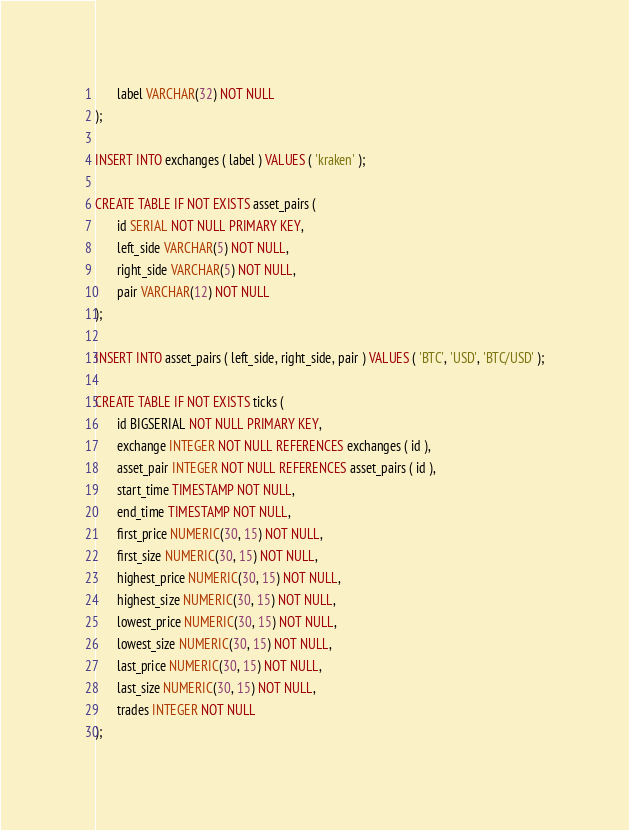<code> <loc_0><loc_0><loc_500><loc_500><_SQL_>       label VARCHAR(32) NOT NULL
);

INSERT INTO exchanges ( label ) VALUES ( 'kraken' );

CREATE TABLE IF NOT EXISTS asset_pairs (
       id SERIAL NOT NULL PRIMARY KEY,
       left_side VARCHAR(5) NOT NULL,
       right_side VARCHAR(5) NOT NULL,
       pair VARCHAR(12) NOT NULL
);

INSERT INTO asset_pairs ( left_side, right_side, pair ) VALUES ( 'BTC', 'USD', 'BTC/USD' );

CREATE TABLE IF NOT EXISTS ticks (
       id BIGSERIAL NOT NULL PRIMARY KEY,
       exchange INTEGER NOT NULL REFERENCES exchanges ( id ),
       asset_pair INTEGER NOT NULL REFERENCES asset_pairs ( id ),
       start_time TIMESTAMP NOT NULL,
       end_time TIMESTAMP NOT NULL,
       first_price NUMERIC(30, 15) NOT NULL,
       first_size NUMERIC(30, 15) NOT NULL,
       highest_price NUMERIC(30, 15) NOT NULL,
       highest_size NUMERIC(30, 15) NOT NULL,
       lowest_price NUMERIC(30, 15) NOT NULL,
       lowest_size NUMERIC(30, 15) NOT NULL,
       last_price NUMERIC(30, 15) NOT NULL,
       last_size NUMERIC(30, 15) NOT NULL,
       trades INTEGER NOT NULL
);
</code> 